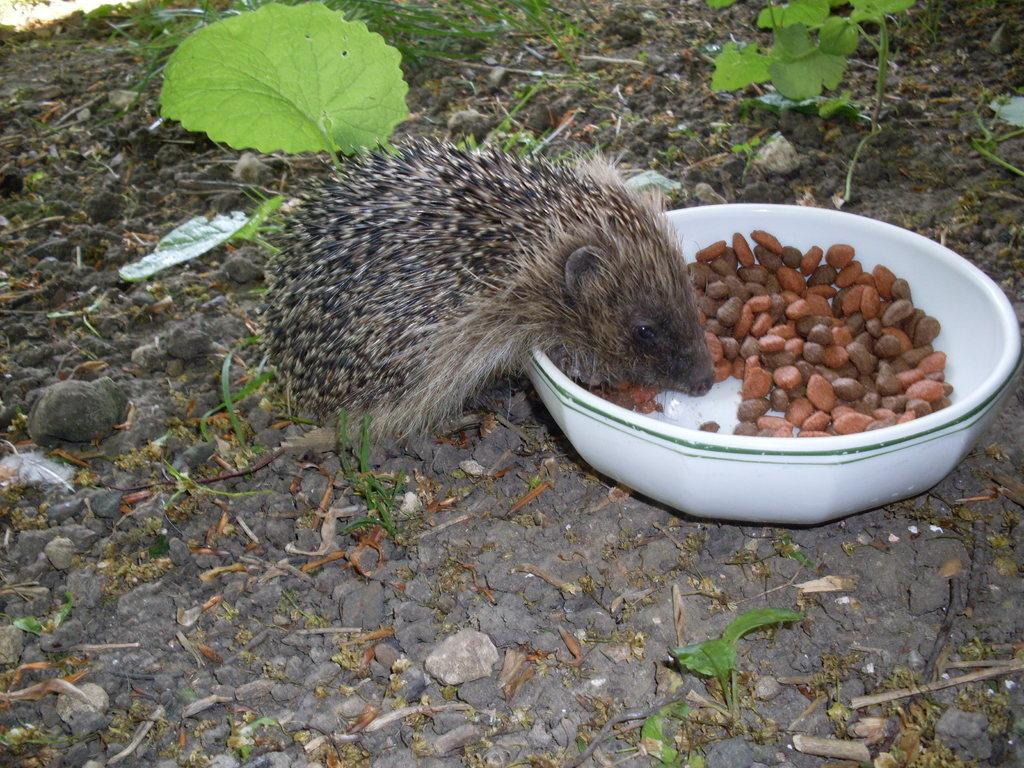What animal can be seen in the image? There is a porcupine in the image. What is in the bowl that is visible in the image? There is a bowl with food in the image. Where is the bowl placed in the image? The bowl is placed on the ground. What can be seen in the background of the image? There are plants and the ground visible in the background of the image. What type of spoon is being used by the porcupine to make a wish in the basin? There is no spoon, wish, or basin present in the image; it features a porcupine and a bowl with food on the ground. 